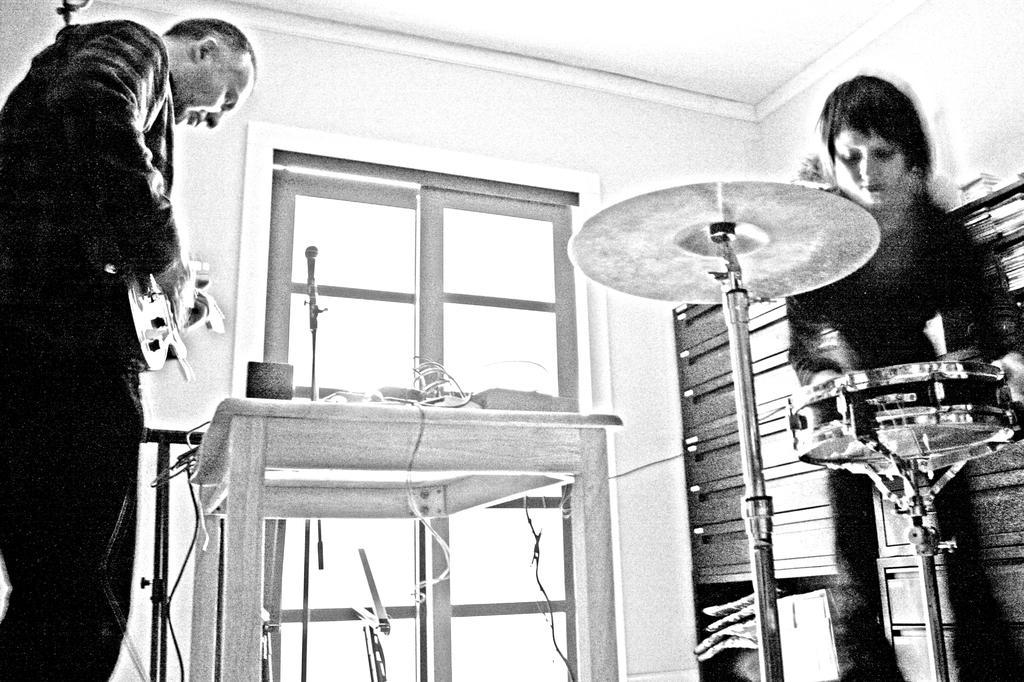Describe this image in one or two sentences. This is a black and white image clicked inside the room. On the right side of the image there is a person standing and holding the table. On the left side of the image there is a man holding a guitar in hands and looking downwards. In front of this person there is a table. In the background there is a window. 